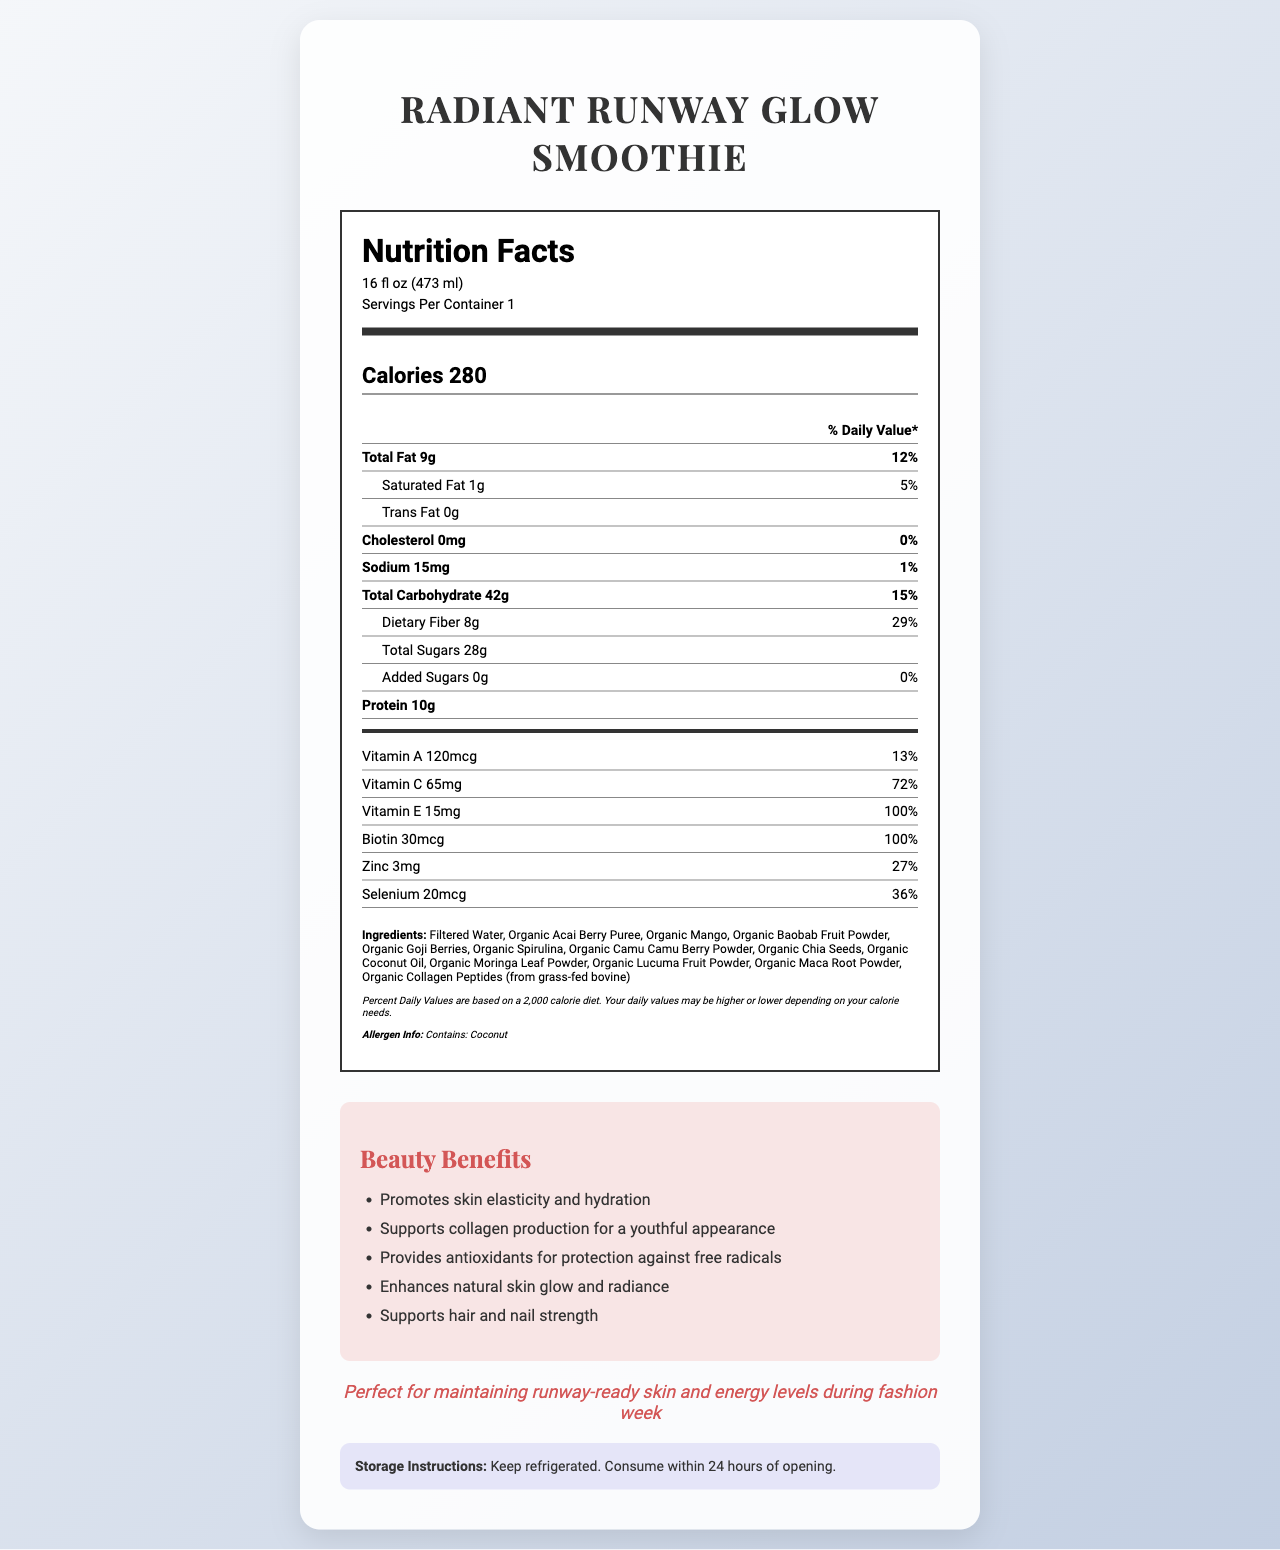what is the serving size? The serving size is clearly stated at the top of the Nutrition Facts section.
Answer: 16 fl oz (473 ml) How much fat is in one serving? The "Total Fat" amount is listed as 9g in the nutrition label.
Answer: 9g What percentage of the daily value of Vitamin C does the smoothie provide? The document states that the "Vitamin C" content is 65mg, which is 72% of the daily value.
Answer: 72% List one ingredient that is not a fruit or a seed. Ingredients like "Organic Moringa Leaf Powder" are not fruits or seeds.
Answer: Organic Moringa Leaf Powder Does the smoothie contain any allergens? If so, which? The allergen information section states that this product contains coconut.
Answer: Yes, coconut How many grams of protein are in one serving of the smoothie? The protein content is listed as 10g under the main nutrients.
Answer: 10g Which nutrient has the highest daily value percentage? A. Vitamin A B. Zinc C. Vitamin E The document lists "Vitamin E" with the highest daily value of 100%.
Answer: C. Vitamin E How much added sugar does the smoothie have? A. 0g B. 10g C. 28g D. 8g The section for "Added Sugars" shows the amount as 0g.
Answer: A. 0g Does the smoothie support collagen production? Under the beauty benefits section, it is clearly stated that the smoothie supports collagen production for a youthful appearance.
Answer: Yes What is the main idea of the document? The document includes the product name, serving size, nutritional information, beauty benefits, allergen information, and storage instructions, all of which contribute to promoting the smoothie as ideal for models.
Answer: The document provides comprehensive nutrition details and beauty benefits of the "Radiant Runway Glow Smoothie," highlighting its exotic ingredients and suitability for fashion models looking to enhance their skin's natural glow and maintain energy levels. How many minutes of exercise is recommended with this smoothie? The document does not provide any recommendations regarding exercise.
Answer: Not enough information What is the total carbohydrate content? The "Total Carbohydrate" content is listed as 42g in the nutrition label.
Answer: 42g Why is this smoothie ideal for models? A. High energy B. Good taste C. Skin benefits The model appeal section mentions maintaining runway-ready skin and energy levels, primarily focusing on skin benefits.
Answer: C. Skin benefits Can the smoothie be stored outside of the refrigerator? (Yes/No) The storage instructions advise to "Keep refrigerated. Consume within 24 hours of opening."
Answer: No 